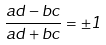<formula> <loc_0><loc_0><loc_500><loc_500>\frac { a d - b c } { a d + b c } = \pm 1</formula> 